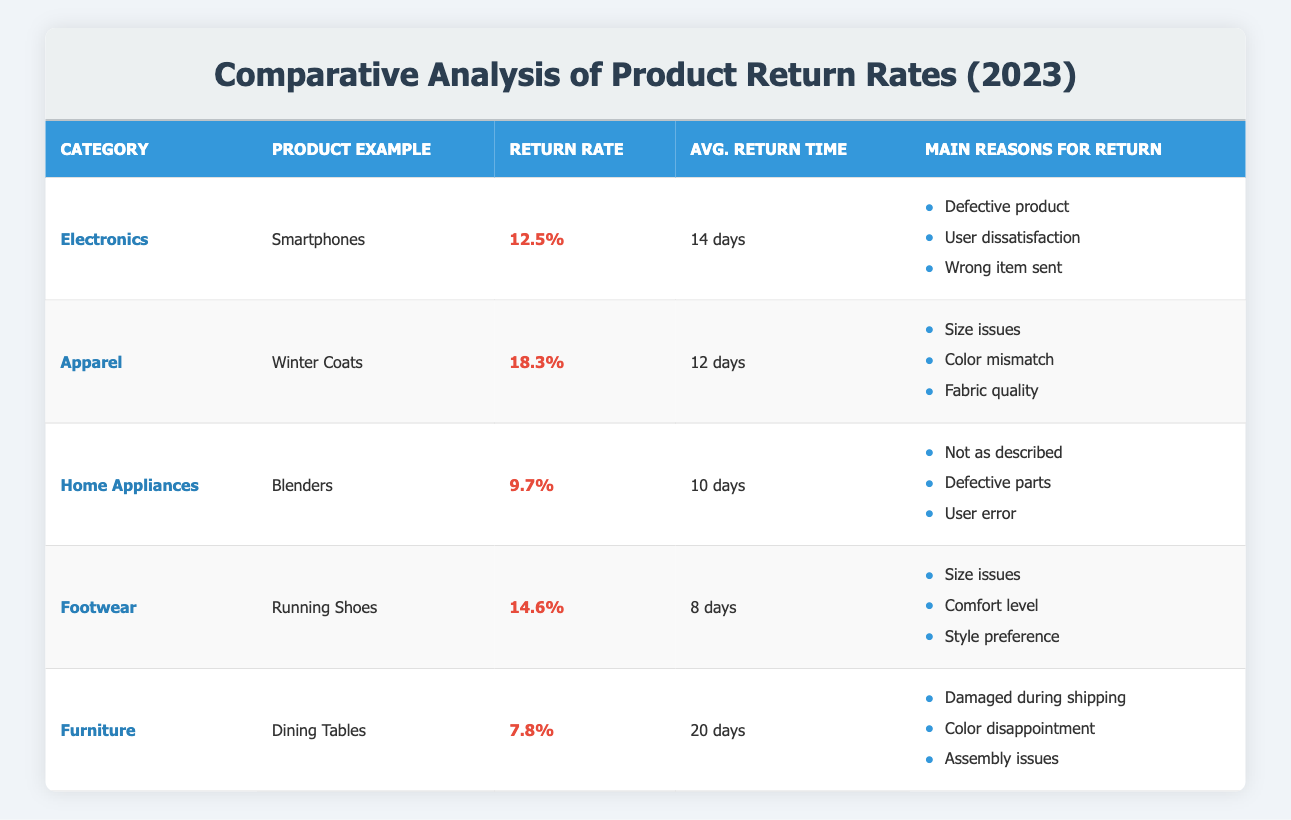What is the return rate percentage for Winter Coats? The table shows the data for Apparel, specifically Winter Coats, whose return rate percentage is listed as 18.3%.
Answer: 18.3% Which category has the highest average return time? From the table, the category with the highest average return time is Furniture, with an average return time of 20 days.
Answer: Furniture What is the average return rate percentage across all categories? To find the average return rate, we sum the return rates for all categories: (12.5 + 18.3 + 9.7 + 14.6 + 7.8) = 63.9, and then divide by the number of categories (5) to get 63.9/5 = 12.78%.
Answer: 12.78% Is the return rate for Electronics higher than that for Home Appliances? The return rate for Electronics is 12.5%, while for Home Appliances it is 9.7%. Since 12.5% is greater than 9.7%, the statement is true.
Answer: Yes What is the difference in return rates between the Apparel and Footwear categories? The return rate for Apparel is 18.3% and for Footwear, it is 14.6%. The difference is calculated as 18.3% - 14.6% = 3.7%.
Answer: 3.7% Which product example has the lowest return rate? The table shows that the product example with the lowest return rate percentage is Dining Tables within the Furniture category, having a return rate of 7.8%.
Answer: Dining Tables Are there any categories where the main reasons for return include size issues? Yes, both the Apparel (Winter Coats) and Footwear (Running Shoes) categories list "Size issues" as a main reason for return. This confirms the categories experienced issues related to sizing.
Answer: Yes What is the highest return rate percentage among the categories listed? The maximum return rate percentage is found under the Apparel category for Winter Coats, which is 18.3%. Thus, it has the highest percentage listed in the table.
Answer: 18.3% Which category's main reasons for return include "Defective product"? The Electronics category lists "Defective product" among its main reasons for return, indicating that this issue is prevalent within that category.
Answer: Electronics 